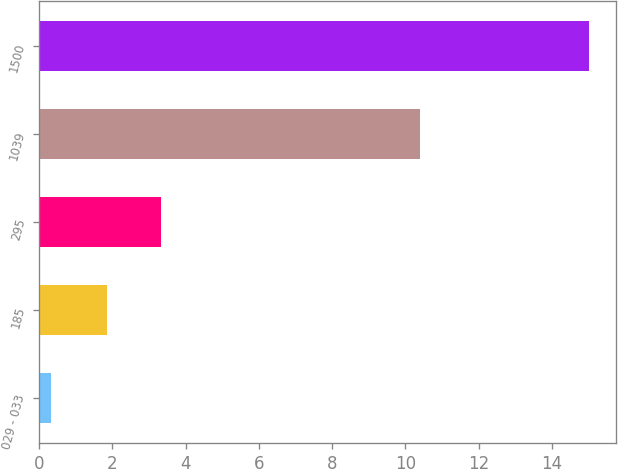Convert chart. <chart><loc_0><loc_0><loc_500><loc_500><bar_chart><fcel>029 - 033<fcel>185<fcel>295<fcel>1039<fcel>1500<nl><fcel>0.32<fcel>1.85<fcel>3.32<fcel>10.39<fcel>15<nl></chart> 